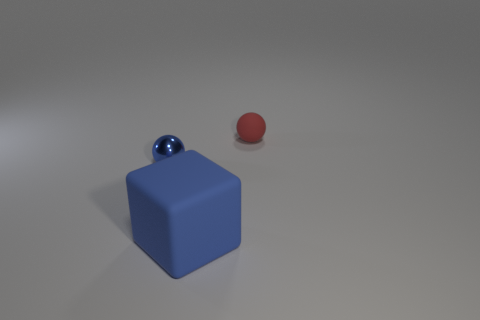Are there any other things that have the same size as the rubber cube?
Your answer should be very brief. No. How many small things are green metal cubes or red spheres?
Give a very brief answer. 1. Are any large gray cylinders visible?
Your answer should be compact. No. There is a object that is the same material as the tiny red ball; what size is it?
Make the answer very short. Large. Does the big thing have the same material as the small blue object?
Offer a very short reply. No. How many other objects are there of the same material as the small blue ball?
Give a very brief answer. 0. What number of objects are right of the metallic sphere and behind the blue matte thing?
Offer a very short reply. 1. What is the color of the rubber block?
Make the answer very short. Blue. There is another tiny thing that is the same shape as the small blue thing; what material is it?
Provide a succinct answer. Rubber. Are there any other things that are the same material as the blue sphere?
Ensure brevity in your answer.  No. 